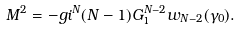<formula> <loc_0><loc_0><loc_500><loc_500>M ^ { 2 } = - g i ^ { N } ( N - 1 ) G _ { 1 } ^ { N - 2 } w _ { N - 2 } ( \gamma _ { 0 } ) .</formula> 